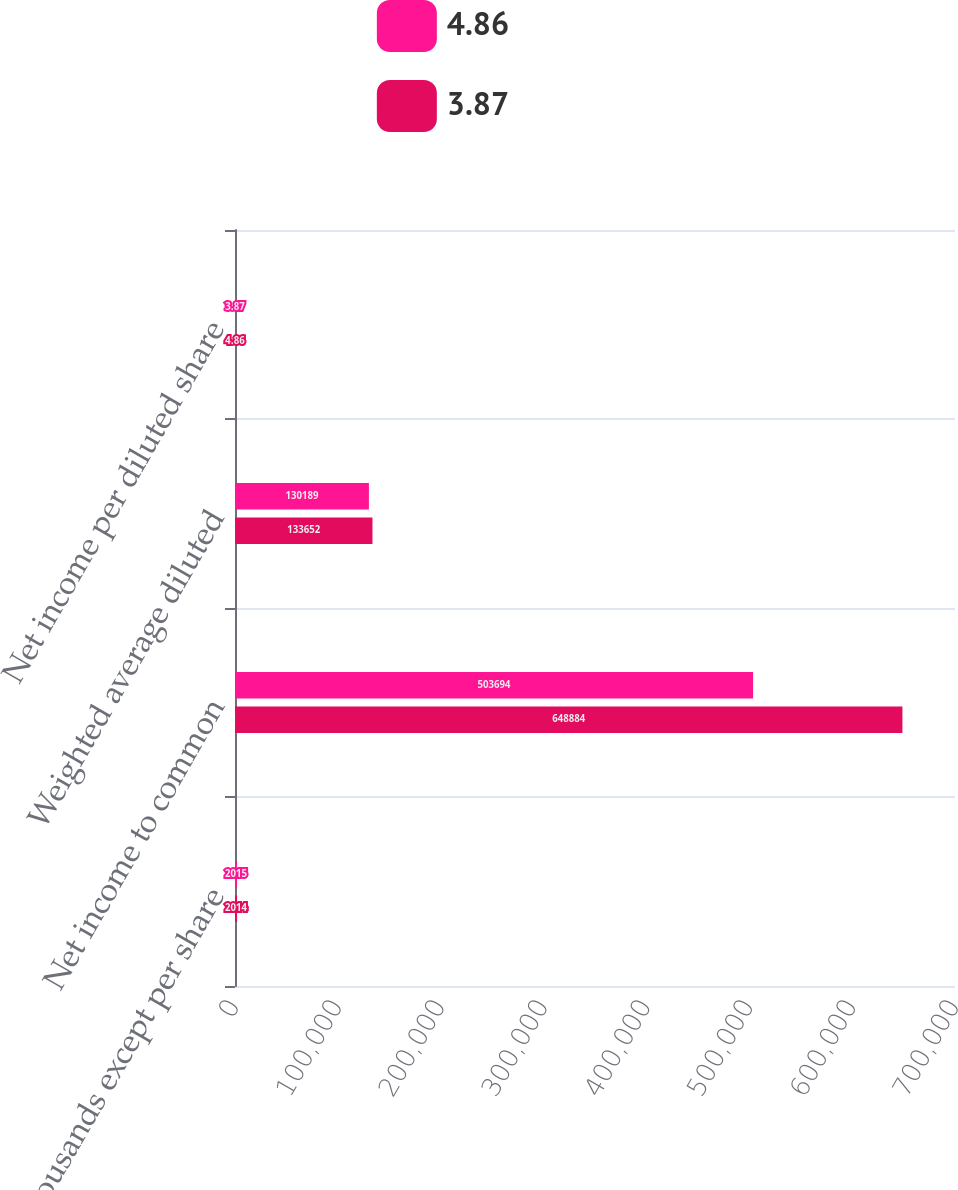Convert chart. <chart><loc_0><loc_0><loc_500><loc_500><stacked_bar_chart><ecel><fcel>(In thousands except per share<fcel>Net income to common<fcel>Weighted average diluted<fcel>Net income per diluted share<nl><fcel>4.86<fcel>2015<fcel>503694<fcel>130189<fcel>3.87<nl><fcel>3.87<fcel>2014<fcel>648884<fcel>133652<fcel>4.86<nl></chart> 